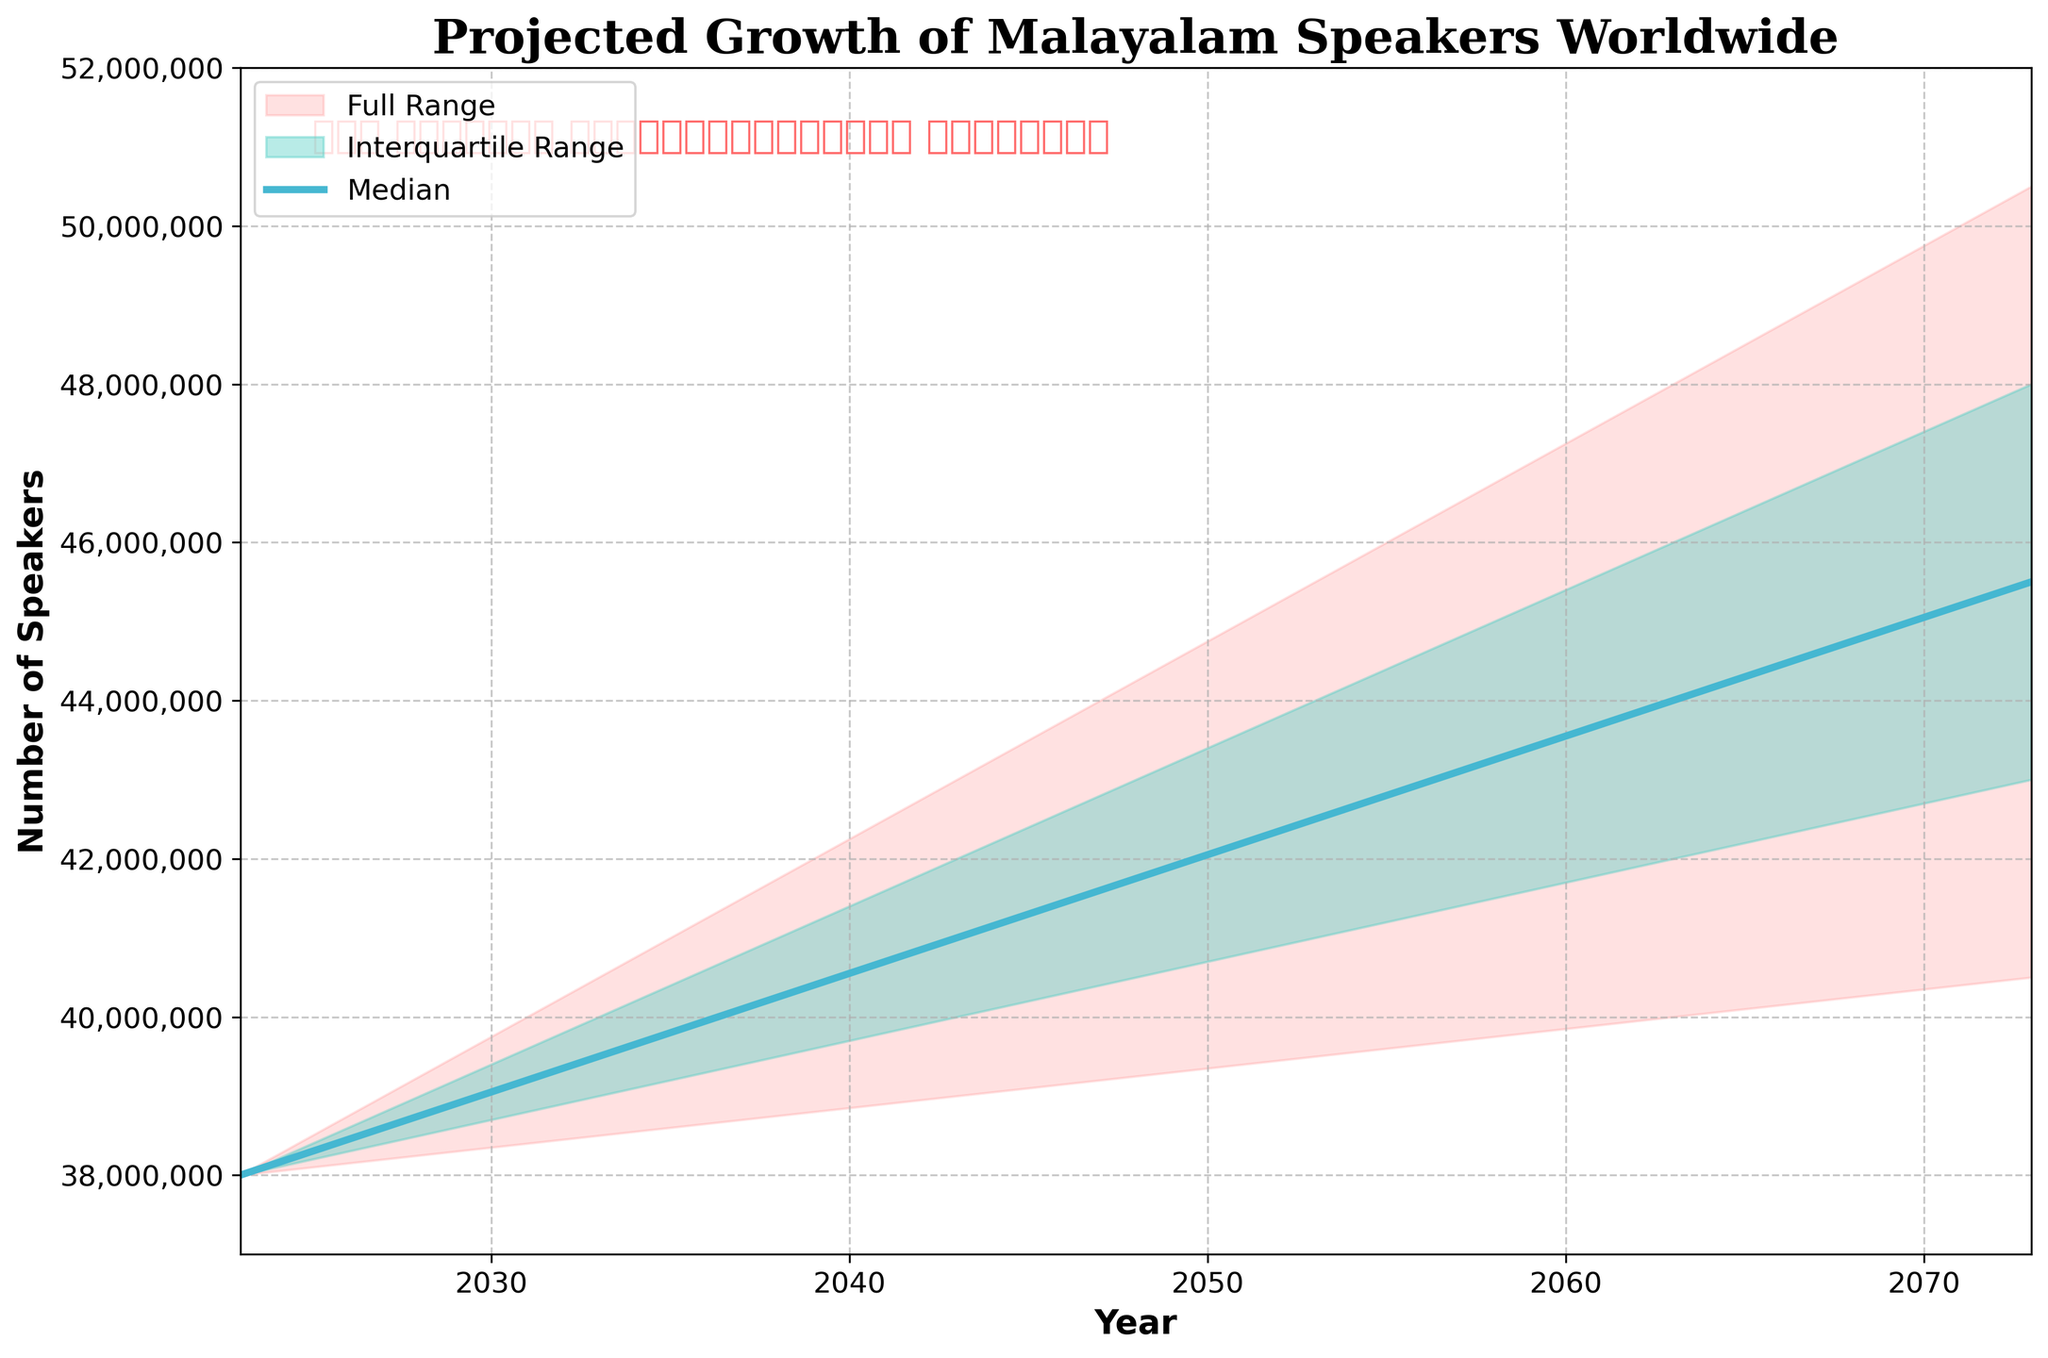What is the title of the chart? The title of the chart is usually written at the top of the chart. Looking at the rendered figure, the title reads "Projected Growth of Malayalam Speakers Worldwide".
Answer: Projected Growth of Malayalam Speakers Worldwide What are the years covered in this projection? By examining the x-axis of the chart, you can see the years listed. The years range from 2023 to 2073.
Answer: 2023-2073 How many projection data points are presented on the chart? By counting the distinct year markers on the x-axis, we can see there are 6 distinct years: 2023, 2033, 2043, 2053, 2063, and 2073.
Answer: 6 What is the color used to represent the median projection line? The median line is clearly marked with a specific color in the chart, which is a shade of blue. So the color used for the median line is blue.
Answer: Blue By how much is the upper bound expected to increase from 2023 to 2073? The upper bound for 2023 is 38,000,000, and for 2073 it is 50,500,000. The increase can be calculated as 50,500,000 - 38,000,000.
Answer: 12,500,000 What is the expected median number of Malayalam speakers in 2053? Looking at the median line (blue) for the year 2053 on the x-axis, the corresponding number on the y-axis is 42,500,000.
Answer: 42,500,000 Which year shows the highest upper bound projection? By comparing the upper bound numbers at each year given on the chart (which increases over time), the highest upper bound projection is seen in 2073 with 50,500,000.
Answer: 2073 In which year is the lower bound expected to first reach 40,000,000? By examining the lower bound line (red shade) and its values, the year corresponding to when it first reaches 40,000,000 is 2063.
Answer: 2063 What is the interquartile range (difference between 75th and 25th percentiles) in 2063? The interquartile range in 2063 can be found by subtracting the 25th percentile (42,000,000) from the 75th percentile (46,000,000). This gives an interquartile range of 4,000,000.
Answer: 4,000,000 